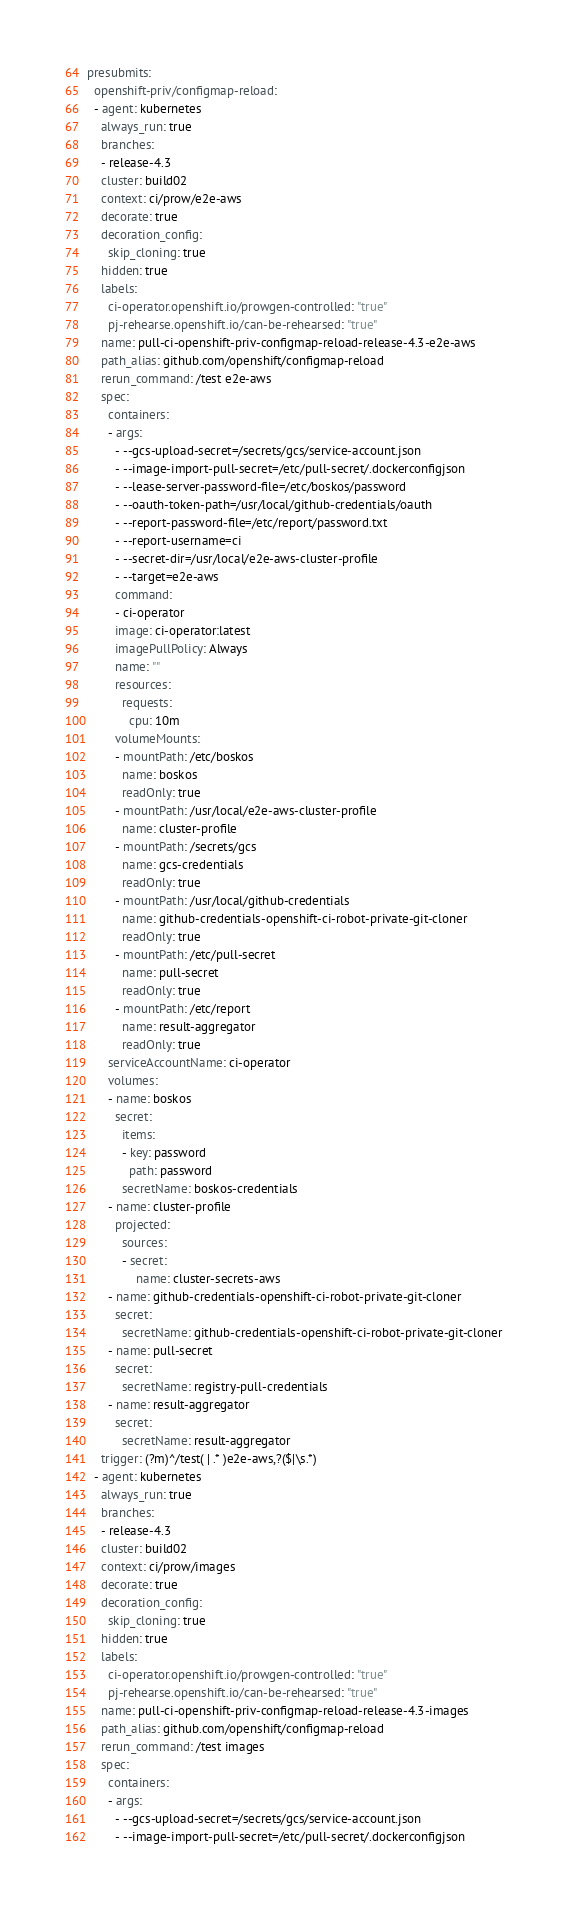Convert code to text. <code><loc_0><loc_0><loc_500><loc_500><_YAML_>presubmits:
  openshift-priv/configmap-reload:
  - agent: kubernetes
    always_run: true
    branches:
    - release-4.3
    cluster: build02
    context: ci/prow/e2e-aws
    decorate: true
    decoration_config:
      skip_cloning: true
    hidden: true
    labels:
      ci-operator.openshift.io/prowgen-controlled: "true"
      pj-rehearse.openshift.io/can-be-rehearsed: "true"
    name: pull-ci-openshift-priv-configmap-reload-release-4.3-e2e-aws
    path_alias: github.com/openshift/configmap-reload
    rerun_command: /test e2e-aws
    spec:
      containers:
      - args:
        - --gcs-upload-secret=/secrets/gcs/service-account.json
        - --image-import-pull-secret=/etc/pull-secret/.dockerconfigjson
        - --lease-server-password-file=/etc/boskos/password
        - --oauth-token-path=/usr/local/github-credentials/oauth
        - --report-password-file=/etc/report/password.txt
        - --report-username=ci
        - --secret-dir=/usr/local/e2e-aws-cluster-profile
        - --target=e2e-aws
        command:
        - ci-operator
        image: ci-operator:latest
        imagePullPolicy: Always
        name: ""
        resources:
          requests:
            cpu: 10m
        volumeMounts:
        - mountPath: /etc/boskos
          name: boskos
          readOnly: true
        - mountPath: /usr/local/e2e-aws-cluster-profile
          name: cluster-profile
        - mountPath: /secrets/gcs
          name: gcs-credentials
          readOnly: true
        - mountPath: /usr/local/github-credentials
          name: github-credentials-openshift-ci-robot-private-git-cloner
          readOnly: true
        - mountPath: /etc/pull-secret
          name: pull-secret
          readOnly: true
        - mountPath: /etc/report
          name: result-aggregator
          readOnly: true
      serviceAccountName: ci-operator
      volumes:
      - name: boskos
        secret:
          items:
          - key: password
            path: password
          secretName: boskos-credentials
      - name: cluster-profile
        projected:
          sources:
          - secret:
              name: cluster-secrets-aws
      - name: github-credentials-openshift-ci-robot-private-git-cloner
        secret:
          secretName: github-credentials-openshift-ci-robot-private-git-cloner
      - name: pull-secret
        secret:
          secretName: registry-pull-credentials
      - name: result-aggregator
        secret:
          secretName: result-aggregator
    trigger: (?m)^/test( | .* )e2e-aws,?($|\s.*)
  - agent: kubernetes
    always_run: true
    branches:
    - release-4.3
    cluster: build02
    context: ci/prow/images
    decorate: true
    decoration_config:
      skip_cloning: true
    hidden: true
    labels:
      ci-operator.openshift.io/prowgen-controlled: "true"
      pj-rehearse.openshift.io/can-be-rehearsed: "true"
    name: pull-ci-openshift-priv-configmap-reload-release-4.3-images
    path_alias: github.com/openshift/configmap-reload
    rerun_command: /test images
    spec:
      containers:
      - args:
        - --gcs-upload-secret=/secrets/gcs/service-account.json
        - --image-import-pull-secret=/etc/pull-secret/.dockerconfigjson</code> 